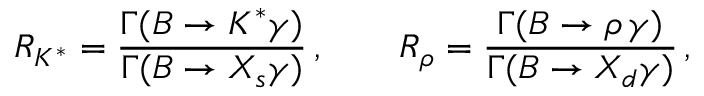<formula> <loc_0><loc_0><loc_500><loc_500>R _ { K ^ { * } } = { \frac { \Gamma ( B \to K ^ { * } \gamma ) } { \Gamma ( B \to X _ { s } \gamma ) } } \, , \quad R _ { \rho } = { \frac { \Gamma ( B \to \rho \, \gamma ) } { \Gamma ( B \to X _ { d } \gamma ) } } \, ,</formula> 